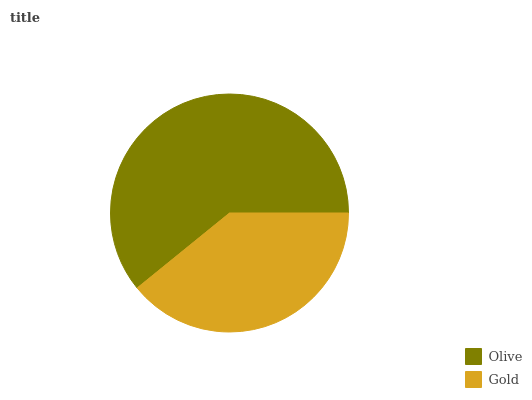Is Gold the minimum?
Answer yes or no. Yes. Is Olive the maximum?
Answer yes or no. Yes. Is Gold the maximum?
Answer yes or no. No. Is Olive greater than Gold?
Answer yes or no. Yes. Is Gold less than Olive?
Answer yes or no. Yes. Is Gold greater than Olive?
Answer yes or no. No. Is Olive less than Gold?
Answer yes or no. No. Is Olive the high median?
Answer yes or no. Yes. Is Gold the low median?
Answer yes or no. Yes. Is Gold the high median?
Answer yes or no. No. Is Olive the low median?
Answer yes or no. No. 